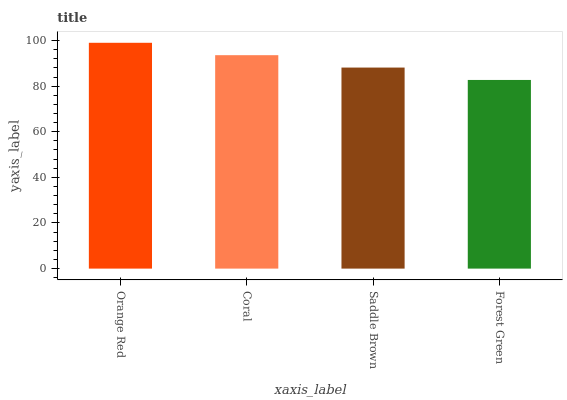Is Forest Green the minimum?
Answer yes or no. Yes. Is Orange Red the maximum?
Answer yes or no. Yes. Is Coral the minimum?
Answer yes or no. No. Is Coral the maximum?
Answer yes or no. No. Is Orange Red greater than Coral?
Answer yes or no. Yes. Is Coral less than Orange Red?
Answer yes or no. Yes. Is Coral greater than Orange Red?
Answer yes or no. No. Is Orange Red less than Coral?
Answer yes or no. No. Is Coral the high median?
Answer yes or no. Yes. Is Saddle Brown the low median?
Answer yes or no. Yes. Is Forest Green the high median?
Answer yes or no. No. Is Orange Red the low median?
Answer yes or no. No. 